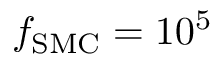Convert formula to latex. <formula><loc_0><loc_0><loc_500><loc_500>f _ { S M C } = 1 0 ^ { 5 }</formula> 